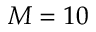Convert formula to latex. <formula><loc_0><loc_0><loc_500><loc_500>M = 1 0</formula> 